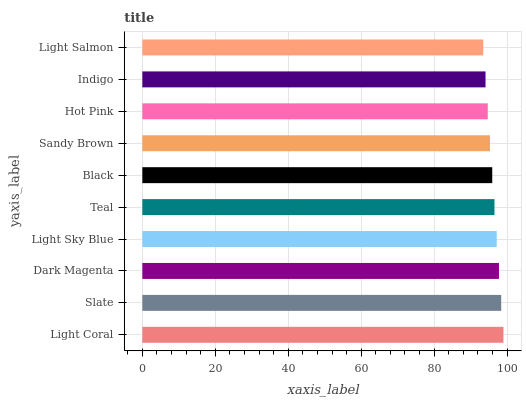Is Light Salmon the minimum?
Answer yes or no. Yes. Is Light Coral the maximum?
Answer yes or no. Yes. Is Slate the minimum?
Answer yes or no. No. Is Slate the maximum?
Answer yes or no. No. Is Light Coral greater than Slate?
Answer yes or no. Yes. Is Slate less than Light Coral?
Answer yes or no. Yes. Is Slate greater than Light Coral?
Answer yes or no. No. Is Light Coral less than Slate?
Answer yes or no. No. Is Teal the high median?
Answer yes or no. Yes. Is Black the low median?
Answer yes or no. Yes. Is Sandy Brown the high median?
Answer yes or no. No. Is Light Salmon the low median?
Answer yes or no. No. 